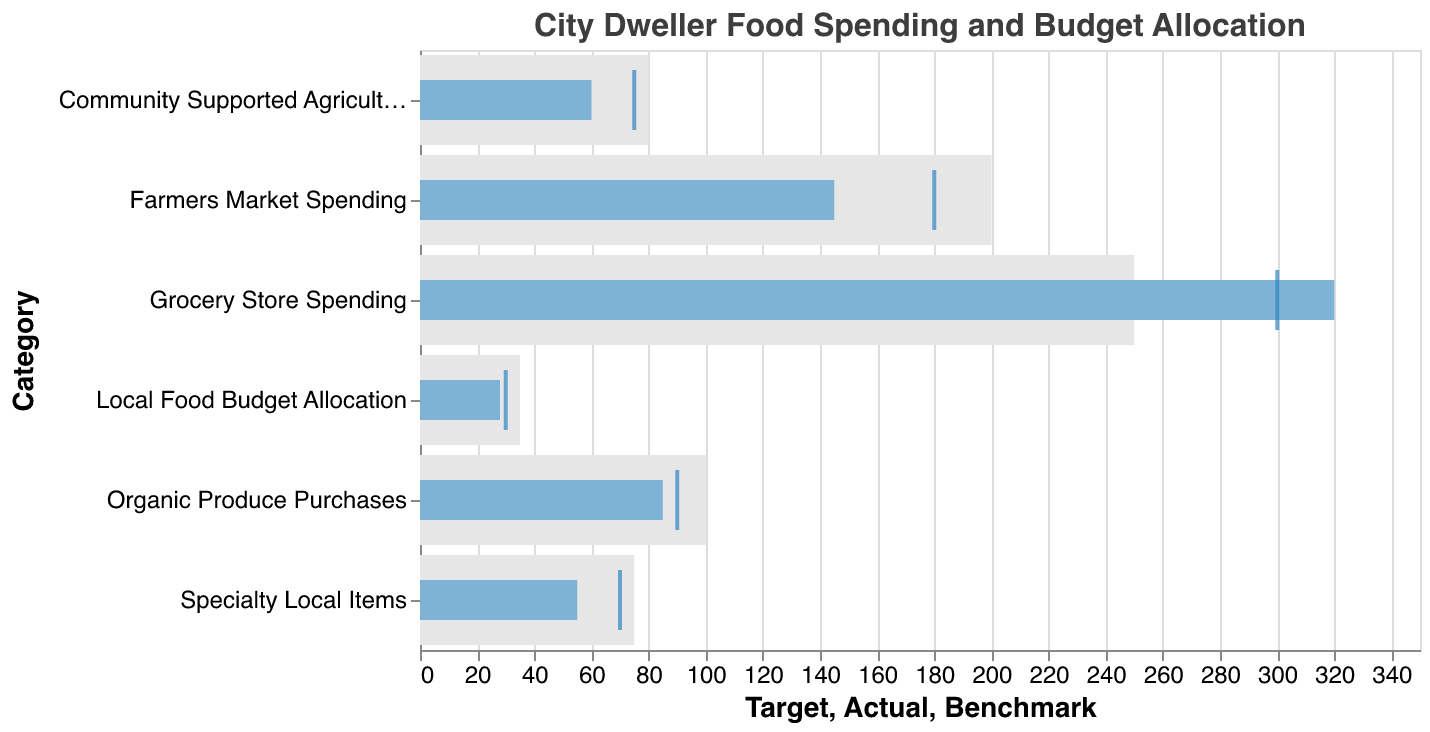What is the title of the chart? The title is positioned at the top of the chart in a larger font size and reads "City Dweller Food Spending and Budget Allocation".
Answer: City Dweller Food Spending and Budget Allocation What category has the highest actual spending? By comparing the lengths of the actual spending bars, it is clear that "Grocery Store Spending" has the highest actual value.
Answer: Grocery Store Spending How much more is the target for Farmers Market Spending compared to its actual spending? The target for Farmers Market Spending is 200, while the actual spending is 145. The difference is 200 - 145.
Answer: 55 Is the actual value of Local Food Budget Allocation meeting its benchmark? The actual value of Local Food Budget Allocation is 28%, and its benchmark is 30%. Since 28% is less than 30%, it is not meeting the benchmark.
Answer: No Which category is closest to meeting its target value? By comparing the differences between the actual values and target values for all categories, the smallest difference is seen in "Community Supported Agriculture (CSA)" which has an actual value of 60 and a target of 80. The difference is 20, which is the smallest among all categories.
Answer: Community Supported Agriculture (CSA) What is the average target value for all categories? Sum all target values (200 + 250 + 35 + 100 + 75 + 80 = 740) and divide by the number of categories (6).
Answer: 123.33 Compare the benchmark and actual values for Organic Produce Purchases. Which is higher? The benchmark for Organic Produce Purchases is 90, and the actual value is 85. The benchmark is higher than the actual value.
Answer: Benchmark Did Grocery Store Spending exceed its benchmark? The benchmark for Grocery Store Spending is 300, and the actual spending is 320. Since 320 is greater than 300, it did exceed the benchmark.
Answer: Yes How much is the difference between the target and benchmark for Specialty Local Items? The target value for Specialty Local Items is 75, and the benchmark value is 70. The difference is 75 - 70.
Answer: 5 